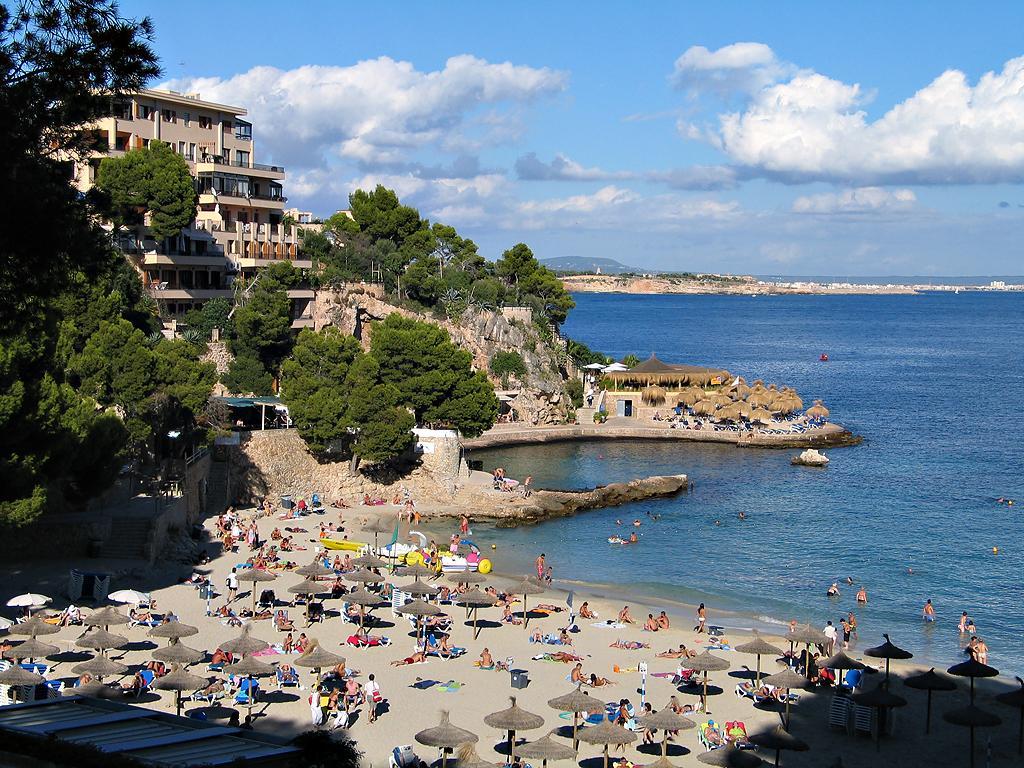In one or two sentences, can you explain what this image depicts? In this image we can see these people on the sand, we can see umbrellas, wall, trees, houses, water and the blue color sky with clouds in the background. 